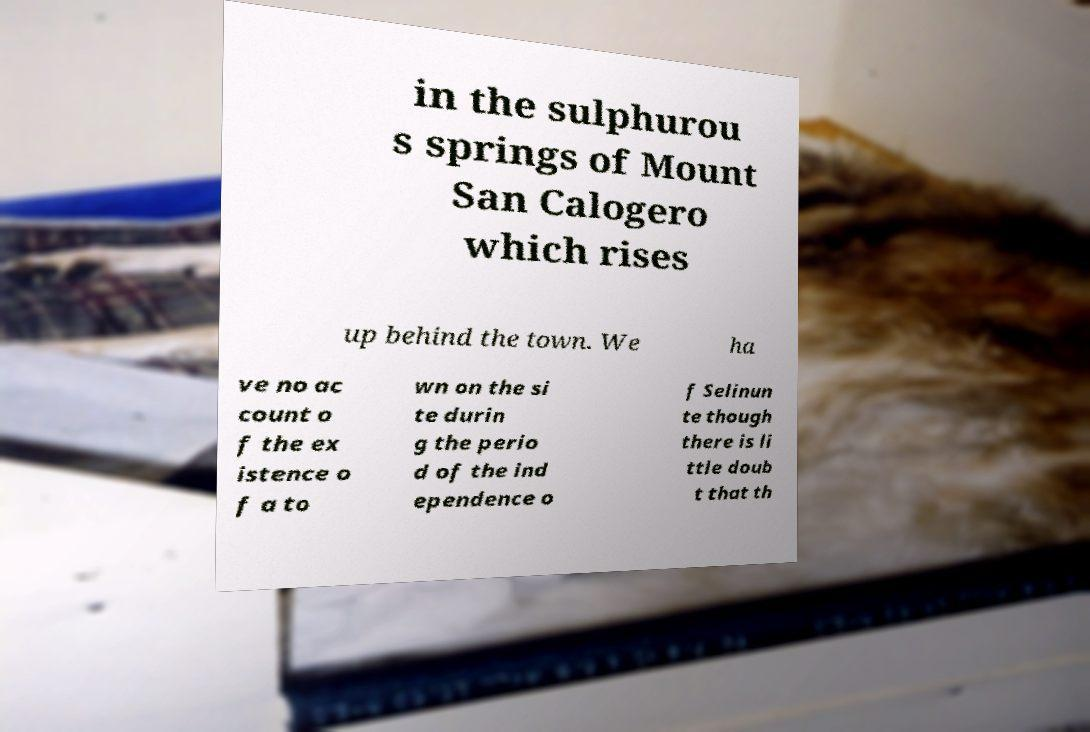I need the written content from this picture converted into text. Can you do that? in the sulphurou s springs of Mount San Calogero which rises up behind the town. We ha ve no ac count o f the ex istence o f a to wn on the si te durin g the perio d of the ind ependence o f Selinun te though there is li ttle doub t that th 